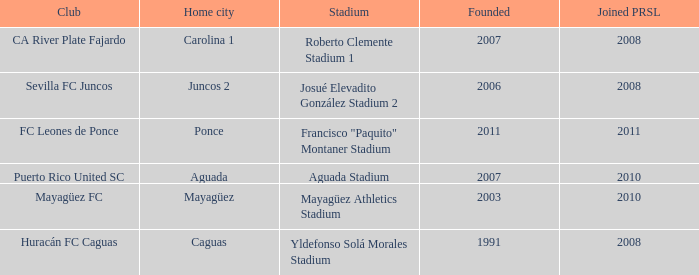What is the club that was founded before 2007, joined prsl in 2008 and the stadium is yldefonso solá morales stadium? Huracán FC Caguas. Could you parse the entire table as a dict? {'header': ['Club', 'Home city', 'Stadium', 'Founded', 'Joined PRSL'], 'rows': [['CA River Plate Fajardo', 'Carolina 1', 'Roberto Clemente Stadium 1', '2007', '2008'], ['Sevilla FC Juncos', 'Juncos 2', 'Josué Elevadito González Stadium 2', '2006', '2008'], ['FC Leones de Ponce', 'Ponce', 'Francisco "Paquito" Montaner Stadium', '2011', '2011'], ['Puerto Rico United SC', 'Aguada', 'Aguada Stadium', '2007', '2010'], ['Mayagüez FC', 'Mayagüez', 'Mayagüez Athletics Stadium', '2003', '2010'], ['Huracán FC Caguas', 'Caguas', 'Yldefonso Solá Morales Stadium', '1991', '2008']]} 